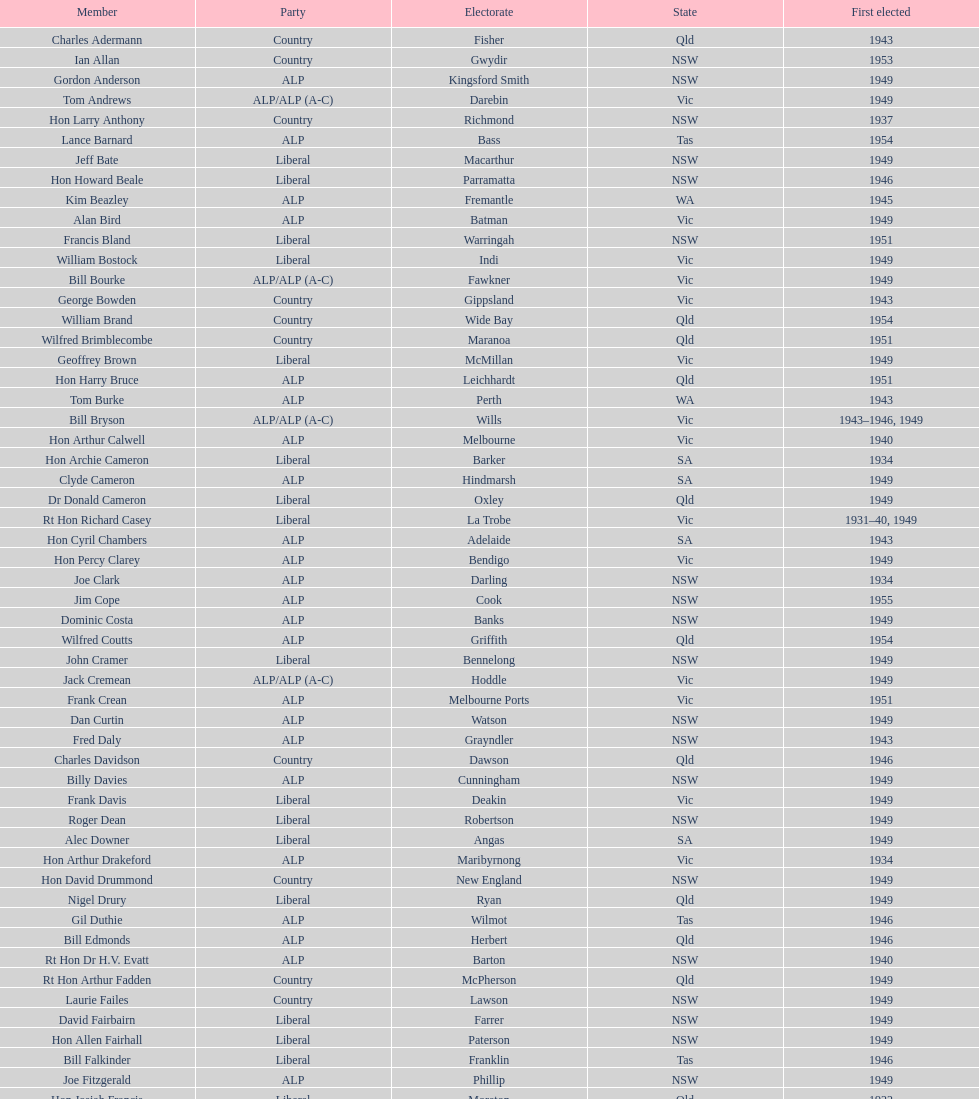Would you mind parsing the complete table? {'header': ['Member', 'Party', 'Electorate', 'State', 'First elected'], 'rows': [['Charles Adermann', 'Country', 'Fisher', 'Qld', '1943'], ['Ian Allan', 'Country', 'Gwydir', 'NSW', '1953'], ['Gordon Anderson', 'ALP', 'Kingsford Smith', 'NSW', '1949'], ['Tom Andrews', 'ALP/ALP (A-C)', 'Darebin', 'Vic', '1949'], ['Hon Larry Anthony', 'Country', 'Richmond', 'NSW', '1937'], ['Lance Barnard', 'ALP', 'Bass', 'Tas', '1954'], ['Jeff Bate', 'Liberal', 'Macarthur', 'NSW', '1949'], ['Hon Howard Beale', 'Liberal', 'Parramatta', 'NSW', '1946'], ['Kim Beazley', 'ALP', 'Fremantle', 'WA', '1945'], ['Alan Bird', 'ALP', 'Batman', 'Vic', '1949'], ['Francis Bland', 'Liberal', 'Warringah', 'NSW', '1951'], ['William Bostock', 'Liberal', 'Indi', 'Vic', '1949'], ['Bill Bourke', 'ALP/ALP (A-C)', 'Fawkner', 'Vic', '1949'], ['George Bowden', 'Country', 'Gippsland', 'Vic', '1943'], ['William Brand', 'Country', 'Wide Bay', 'Qld', '1954'], ['Wilfred Brimblecombe', 'Country', 'Maranoa', 'Qld', '1951'], ['Geoffrey Brown', 'Liberal', 'McMillan', 'Vic', '1949'], ['Hon Harry Bruce', 'ALP', 'Leichhardt', 'Qld', '1951'], ['Tom Burke', 'ALP', 'Perth', 'WA', '1943'], ['Bill Bryson', 'ALP/ALP (A-C)', 'Wills', 'Vic', '1943–1946, 1949'], ['Hon Arthur Calwell', 'ALP', 'Melbourne', 'Vic', '1940'], ['Hon Archie Cameron', 'Liberal', 'Barker', 'SA', '1934'], ['Clyde Cameron', 'ALP', 'Hindmarsh', 'SA', '1949'], ['Dr Donald Cameron', 'Liberal', 'Oxley', 'Qld', '1949'], ['Rt Hon Richard Casey', 'Liberal', 'La Trobe', 'Vic', '1931–40, 1949'], ['Hon Cyril Chambers', 'ALP', 'Adelaide', 'SA', '1943'], ['Hon Percy Clarey', 'ALP', 'Bendigo', 'Vic', '1949'], ['Joe Clark', 'ALP', 'Darling', 'NSW', '1934'], ['Jim Cope', 'ALP', 'Cook', 'NSW', '1955'], ['Dominic Costa', 'ALP', 'Banks', 'NSW', '1949'], ['Wilfred Coutts', 'ALP', 'Griffith', 'Qld', '1954'], ['John Cramer', 'Liberal', 'Bennelong', 'NSW', '1949'], ['Jack Cremean', 'ALP/ALP (A-C)', 'Hoddle', 'Vic', '1949'], ['Frank Crean', 'ALP', 'Melbourne Ports', 'Vic', '1951'], ['Dan Curtin', 'ALP', 'Watson', 'NSW', '1949'], ['Fred Daly', 'ALP', 'Grayndler', 'NSW', '1943'], ['Charles Davidson', 'Country', 'Dawson', 'Qld', '1946'], ['Billy Davies', 'ALP', 'Cunningham', 'NSW', '1949'], ['Frank Davis', 'Liberal', 'Deakin', 'Vic', '1949'], ['Roger Dean', 'Liberal', 'Robertson', 'NSW', '1949'], ['Alec Downer', 'Liberal', 'Angas', 'SA', '1949'], ['Hon Arthur Drakeford', 'ALP', 'Maribyrnong', 'Vic', '1934'], ['Hon David Drummond', 'Country', 'New England', 'NSW', '1949'], ['Nigel Drury', 'Liberal', 'Ryan', 'Qld', '1949'], ['Gil Duthie', 'ALP', 'Wilmot', 'Tas', '1946'], ['Bill Edmonds', 'ALP', 'Herbert', 'Qld', '1946'], ['Rt Hon Dr H.V. Evatt', 'ALP', 'Barton', 'NSW', '1940'], ['Rt Hon Arthur Fadden', 'Country', 'McPherson', 'Qld', '1949'], ['Laurie Failes', 'Country', 'Lawson', 'NSW', '1949'], ['David Fairbairn', 'Liberal', 'Farrer', 'NSW', '1949'], ['Hon Allen Fairhall', 'Liberal', 'Paterson', 'NSW', '1949'], ['Bill Falkinder', 'Liberal', 'Franklin', 'Tas', '1946'], ['Joe Fitzgerald', 'ALP', 'Phillip', 'NSW', '1949'], ['Hon Josiah Francis', 'Liberal', 'Moreton', 'Qld', '1922'], ['Allan Fraser', 'ALP', 'Eden-Monaro', 'NSW', '1943'], ['Jim Fraser', 'ALP', 'Australian Capital Territory', 'ACT', '1951'], ['Gordon Freeth', 'Liberal', 'Forrest', 'WA', '1949'], ['Arthur Fuller', 'Country', 'Hume', 'NSW', '1943–49, 1951'], ['Pat Galvin', 'ALP', 'Kingston', 'SA', '1951'], ['Arthur Greenup', 'ALP', 'Dalley', 'NSW', '1953'], ['Charles Griffiths', 'ALP', 'Shortland', 'NSW', '1949'], ['Jo Gullett', 'Liberal', 'Henty', 'Vic', '1946'], ['Len Hamilton', 'Country', 'Canning', 'WA', '1946'], ['Rt Hon Eric Harrison', 'Liberal', 'Wentworth', 'NSW', '1931'], ['Jim Harrison', 'ALP', 'Blaxland', 'NSW', '1949'], ['Hon Paul Hasluck', 'Liberal', 'Curtin', 'WA', '1949'], ['Hon William Haworth', 'Liberal', 'Isaacs', 'Vic', '1949'], ['Leslie Haylen', 'ALP', 'Parkes', 'NSW', '1943'], ['Rt Hon Harold Holt', 'Liberal', 'Higgins', 'Vic', '1935'], ['John Howse', 'Liberal', 'Calare', 'NSW', '1946'], ['Alan Hulme', 'Liberal', 'Petrie', 'Qld', '1949'], ['William Jack', 'Liberal', 'North Sydney', 'NSW', '1949'], ['Rowley James', 'ALP', 'Hunter', 'NSW', '1928'], ['Hon Herbert Johnson', 'ALP', 'Kalgoorlie', 'WA', '1940'], ['Bob Joshua', 'ALP/ALP (A-C)', 'Ballaarat', 'ALP', '1951'], ['Percy Joske', 'Liberal', 'Balaclava', 'Vic', '1951'], ['Hon Wilfrid Kent Hughes', 'Liberal', 'Chisholm', 'Vic', '1949'], ['Stan Keon', 'ALP/ALP (A-C)', 'Yarra', 'Vic', '1949'], ['William Lawrence', 'Liberal', 'Wimmera', 'Vic', '1949'], ['Hon George Lawson', 'ALP', 'Brisbane', 'Qld', '1931'], ['Nelson Lemmon', 'ALP', 'St George', 'NSW', '1943–49, 1954'], ['Hugh Leslie', 'Liberal', 'Moore', 'Country', '1949'], ['Robert Lindsay', 'Liberal', 'Flinders', 'Vic', '1954'], ['Tony Luchetti', 'ALP', 'Macquarie', 'NSW', '1951'], ['Aubrey Luck', 'Liberal', 'Darwin', 'Tas', '1951'], ['Philip Lucock', 'Country', 'Lyne', 'NSW', '1953'], ['Dan Mackinnon', 'Liberal', 'Corangamite', 'Vic', '1949–51, 1953'], ['Hon Norman Makin', 'ALP', 'Sturt', 'SA', '1919–46, 1954'], ['Hon Philip McBride', 'Liberal', 'Wakefield', 'SA', '1931–37, 1937–43 (S), 1946'], ['Malcolm McColm', 'Liberal', 'Bowman', 'Qld', '1949'], ['Rt Hon John McEwen', 'Country', 'Murray', 'Vic', '1934'], ['John McLeay', 'Liberal', 'Boothby', 'SA', '1949'], ['Don McLeod', 'Liberal', 'Wannon', 'ALP', '1940–49, 1951'], ['Hon William McMahon', 'Liberal', 'Lowe', 'NSW', '1949'], ['Rt Hon Robert Menzies', 'Liberal', 'Kooyong', 'Vic', '1934'], ['Dan Minogue', 'ALP', 'West Sydney', 'NSW', '1949'], ['Charles Morgan', 'ALP', 'Reid', 'NSW', '1940–46, 1949'], ['Jack Mullens', 'ALP/ALP (A-C)', 'Gellibrand', 'Vic', '1949'], ['Jock Nelson', 'ALP', 'Northern Territory', 'NT', '1949'], ["William O'Connor", 'ALP', 'Martin', 'NSW', '1946'], ['Hubert Opperman', 'Liberal', 'Corio', 'Vic', '1949'], ['Hon Frederick Osborne', 'Liberal', 'Evans', 'NSW', '1949'], ['Rt Hon Sir Earle Page', 'Country', 'Cowper', 'NSW', '1919'], ['Henry Pearce', 'Liberal', 'Capricornia', 'Qld', '1949'], ['Ted Peters', 'ALP', 'Burke', 'Vic', '1949'], ['Hon Reg Pollard', 'ALP', 'Lalor', 'Vic', '1937'], ['Hon Bill Riordan', 'ALP', 'Kennedy', 'Qld', '1936'], ['Hugh Roberton', 'Country', 'Riverina', 'NSW', '1949'], ['Edgar Russell', 'ALP', 'Grey', 'SA', '1943'], ['Tom Sheehan', 'ALP', 'Cook', 'NSW', '1937'], ['Frank Stewart', 'ALP', 'Lang', 'NSW', '1953'], ['Reginald Swartz', 'Liberal', 'Darling Downs', 'Qld', '1949'], ['Albert Thompson', 'ALP', 'Port Adelaide', 'SA', '1946'], ['Frank Timson', 'Liberal', 'Higinbotham', 'Vic', '1949'], ['Hon Athol Townley', 'Liberal', 'Denison', 'Tas', '1949'], ['Winton Turnbull', 'Country', 'Mallee', 'Vic', '1946'], ['Harry Turner', 'Liberal', 'Bradfield', 'NSW', '1952'], ['Hon Eddie Ward', 'ALP', 'East Sydney', 'NSW', '1931, 1932'], ['David Oliver Watkins', 'ALP', 'Newcastle', 'NSW', '1935'], ['Harry Webb', 'ALP', 'Swan', 'WA', '1954'], ['William Wentworth', 'Liberal', 'Mackellar', 'NSW', '1949'], ['Roy Wheeler', 'Liberal', 'Mitchell', 'NSW', '1949'], ['Gough Whitlam', 'ALP', 'Werriwa', 'NSW', '1952'], ['Bruce Wight', 'Liberal', 'Lilley', 'Qld', '1949']]} Did tom burke run as country or alp party? ALP. 